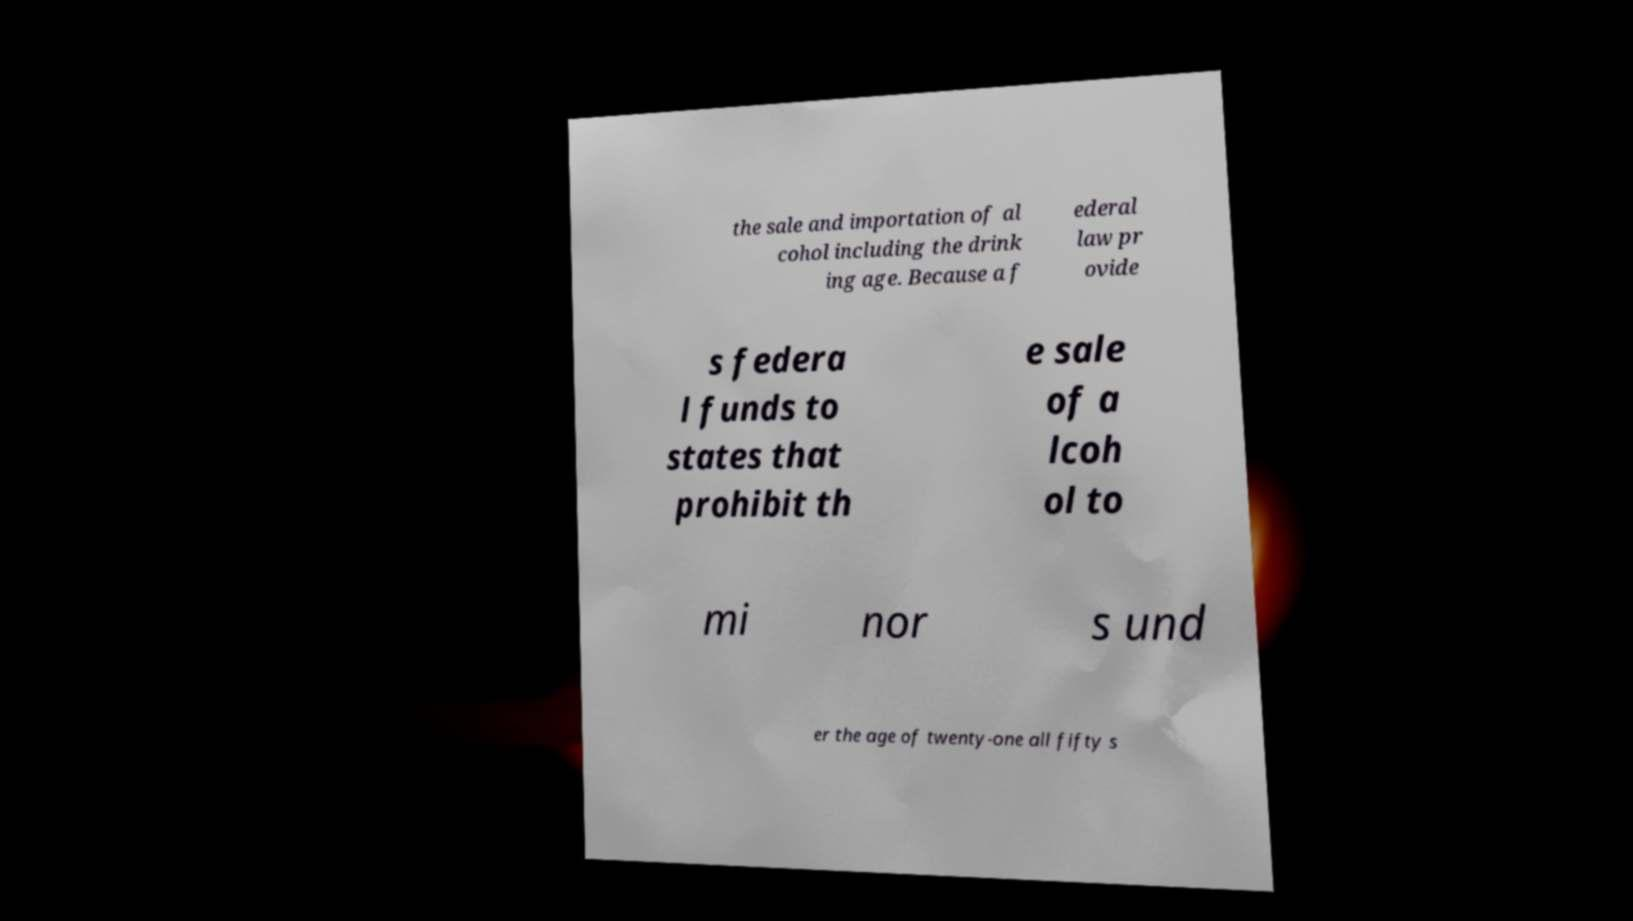Please identify and transcribe the text found in this image. the sale and importation of al cohol including the drink ing age. Because a f ederal law pr ovide s federa l funds to states that prohibit th e sale of a lcoh ol to mi nor s und er the age of twenty-one all fifty s 